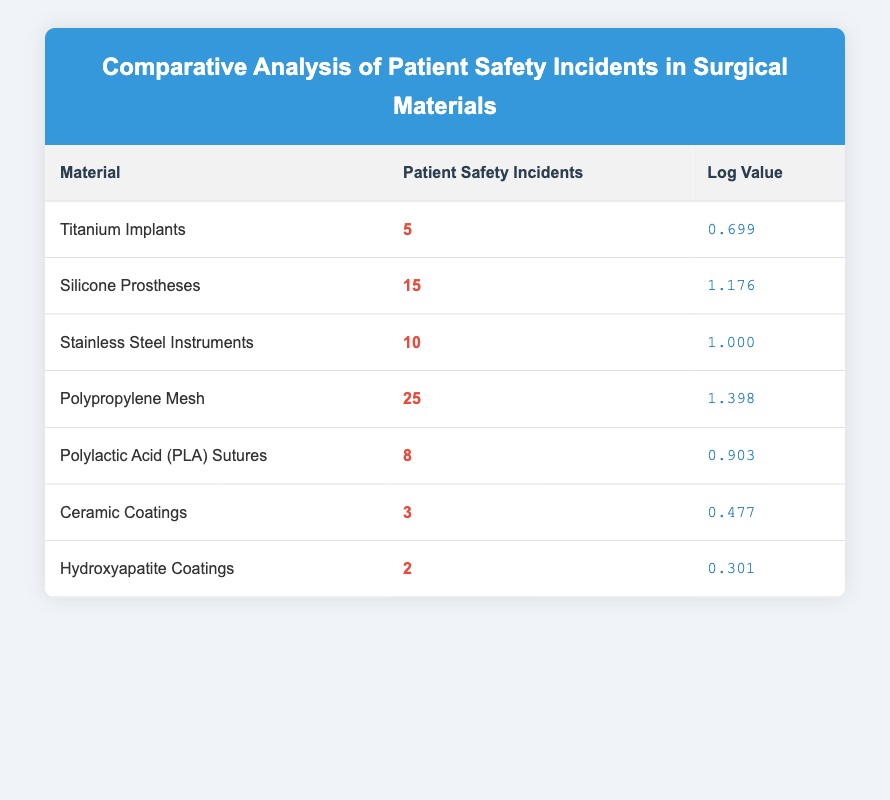What is the log value for Polypropylene Mesh? According to the table, the log value is listed directly next to Polypropylene Mesh, which shows a log value of 1.398.
Answer: 1.398 How many patient safety incidents were reported for Ceramic Coatings? The table clearly shows that there were 3 patient safety incidents associated with Ceramic Coatings.
Answer: 3 Which surgical material has the highest number of patient safety incidents? By reviewing the incidents column, Polypropylene Mesh has the highest count with 25 incidents compared to all other materials.
Answer: Polypropylene Mesh What is the average number of patient safety incidents among all the materials listed? To find the average, first sum the incidents (5 + 15 + 10 + 25 + 8 + 3 + 2 = 68), then divide by the number of materials (7). So, the average is 68 / 7 = 9.71.
Answer: 9.71 Is the log value for Stainless Steel Instruments greater than that for Polylactic Acid Sutures? The log value for Stainless Steel Instruments is 1.000, while for Polylactic Acid Sutures it is 0.903. Since 1.000 is greater than 0.903, the statement is true.
Answer: Yes What is the difference in patient safety incidents between Silicone Prostheses and Hydroxyapatite Coatings? Silicone Prostheses report 15 incidents, while Hydroxyapatite Coatings report 2 incidents. Therefore, the difference is 15 - 2 = 13 incidents.
Answer: 13 Are there any materials listed with fewer than 5 patient safety incidents? Reviewing the incidents for each material shows that Hydroxyapatite Coatings (2 incidents) and Ceramic Coatings (3 incidents) both report fewer than 5 incidents, confirming the existence of such materials.
Answer: Yes What is the total number of patient safety incidents across Titanium Implants, Polylactic Acid Sutures, and Ceramic Coatings? The incidents for these materials are 5 (Titanium Implants) + 8 (Polylactic Acid Sutures) + 3 (Ceramic Coatings), totaling 16 incidents.
Answer: 16 Which materials have a log value greater than 1.0, and how many have this property? Looking at the log values, Polypropylene Mesh (1.398), Silicone Prostheses (1.176), and Stainless Steel Instruments (1.000) are the ones above 1.0, indicating that 3 materials hold this property.
Answer: 3 